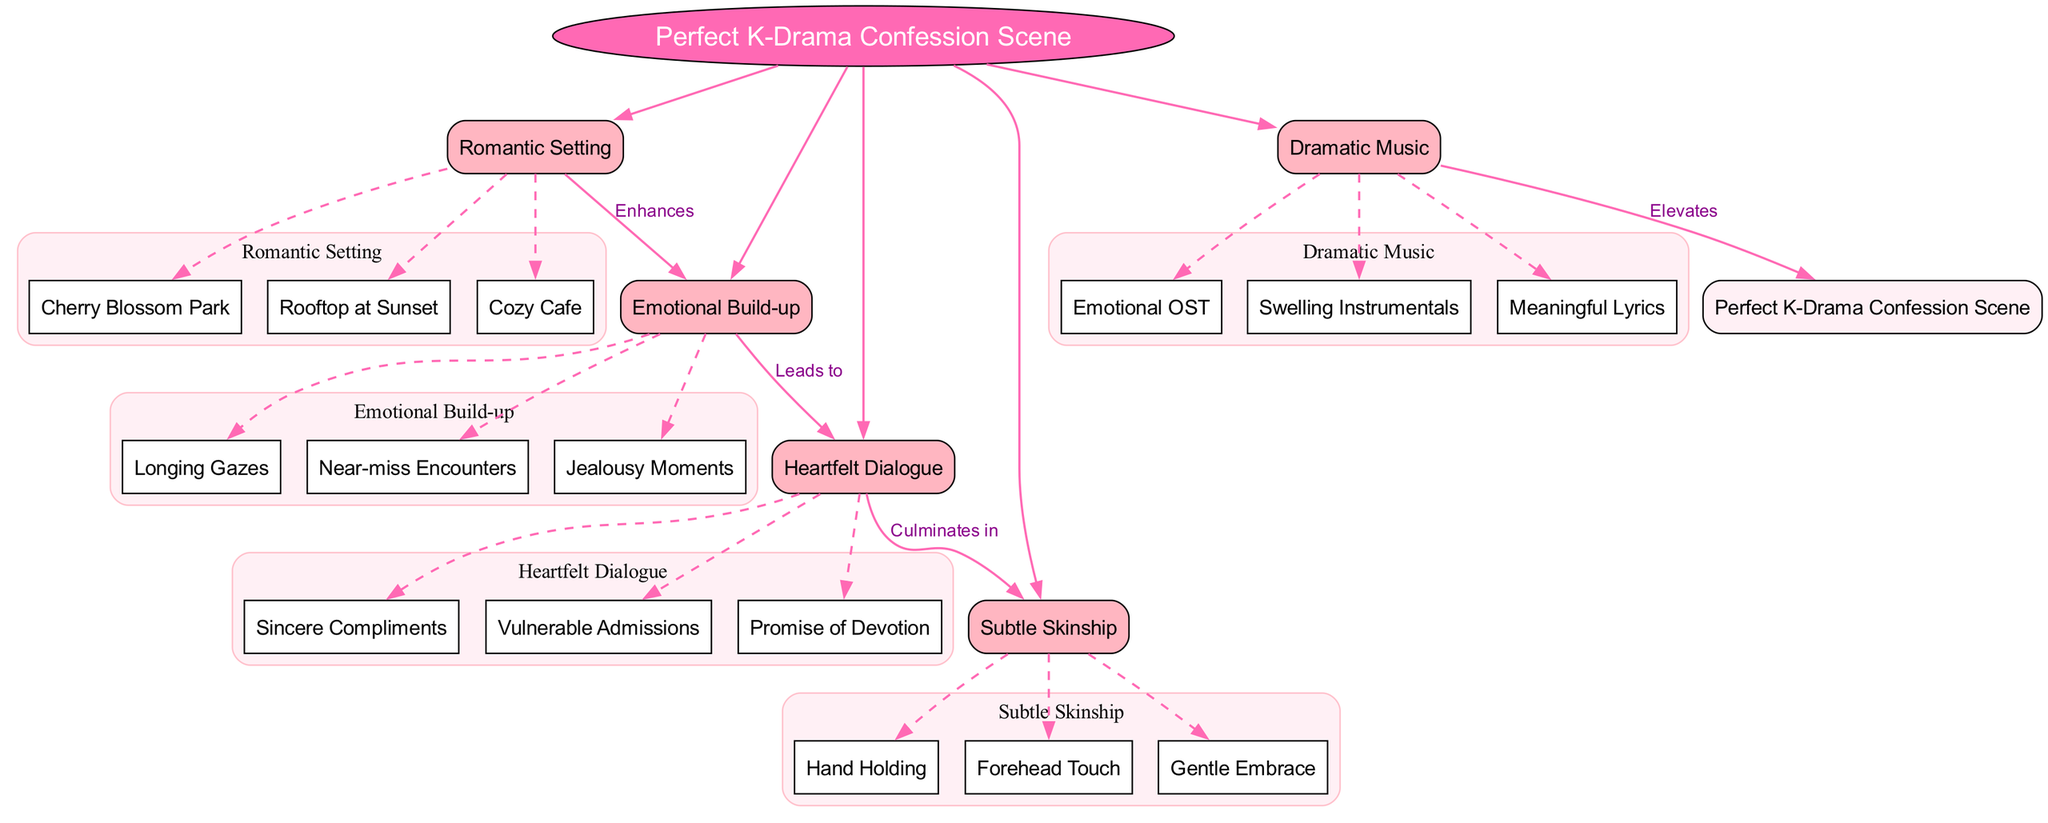What is the central theme of the diagram? The central theme is explicitly labeled at the center of the diagram as "Perfect K-Drama Confession Scene." Therefore, you simply look for the most prominent element in the diagram to find the answer.
Answer: Perfect K-Drama Confession Scene How many key elements are there in the diagram? By counting the number of key elements listed, which are "Romantic Setting," "Emotional Build-up," "Heartfelt Dialogue," "Subtle Skinship," and "Dramatic Music," you find that there are five key elements in total.
Answer: 5 What enhances the emotional build-up? The diagram shows a direct connection with the label "Enhances" from "Romantic Setting" to "Emotional Build-up." This indicates that the romantic setting plays a crucial role in enhancing emotional build-up in a confession scene.
Answer: Romantic Setting What culminates in subtle skinship? The connection labeled "Culminates in" leads from "Heartfelt Dialogue" to "Subtle Skinship." This indicates that after heartfelt dialogue, the next significant action tends to be subtle skinship during a confession scene.
Answer: Heartfelt Dialogue Which sub-element falls under "Dramatic Music"? The sub-elements listed under "Dramatic Music" include "Emotional OST," "Swelling Instrumentals," and "Meaningful Lyrics." By referencing these, we can identify the components specifically associated with dramatic music in the scene.
Answer: Emotional OST How does dramatic music relate to the overall confession scene? The diagram indicates a connection labeled "Elevates" from "Dramatic Music" to the central theme "Perfect K-Drama Confession Scene," suggesting that dramatic music enhances or elevates the scene overall.
Answer: Elevates List one sub-element under "Romantic Setting." The sub-elements under "Romantic Setting" are "Cherry Blossom Park," "Rooftop at Sunset," and "Cozy Cafe." By naming any of these, you provide a specific example of a romantic setting in K-dramas.
Answer: Cherry Blossom Park What leads to heartfelt dialogue? There is a direct relationship labeled "Leads to" that shows "Emotional Build-up" leads to "Heartfelt Dialogue." This indicates that the emotional experiences build up before heartfelt dialogue is expressed in a confession scene.
Answer: Emotional Build-up 